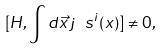Convert formula to latex. <formula><loc_0><loc_0><loc_500><loc_500>[ H , \int d \vec { x } \, j _ { \ } s ^ { i } ( x ) ] \neq 0 ,</formula> 